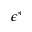Convert formula to latex. <formula><loc_0><loc_0><loc_500><loc_500>\epsilon ^ { \ast }</formula> 